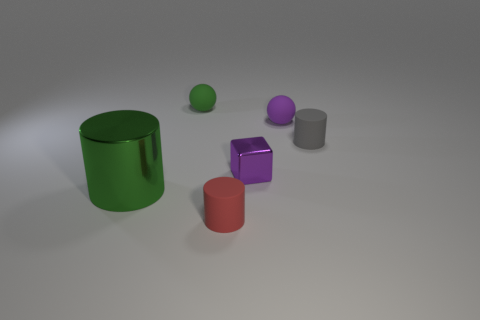How many objects are there in total, and can you describe their shapes? There are five objects in total: one large green cylinder, one red cylinder, one grey cylinder, one purple cube, and one green sphere. 